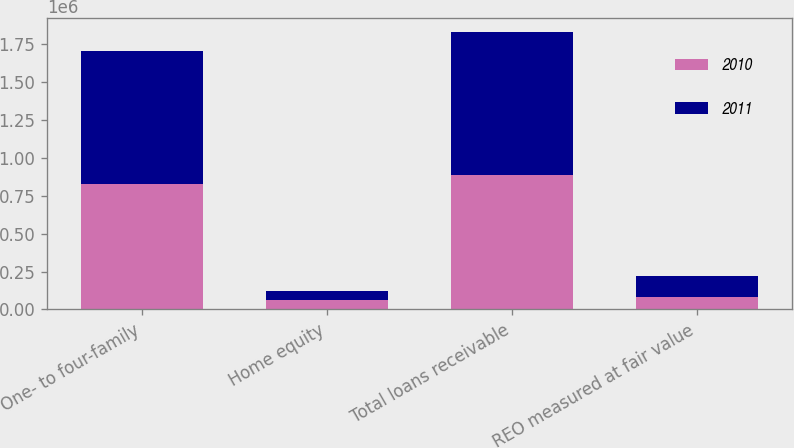Convert chart. <chart><loc_0><loc_0><loc_500><loc_500><stacked_bar_chart><ecel><fcel>One- to four-family<fcel>Home equity<fcel>Total loans receivable<fcel>REO measured at fair value<nl><fcel>2010<fcel>823338<fcel>61163<fcel>884501<fcel>81505<nl><fcel>2011<fcel>880044<fcel>61940<fcel>941984<fcel>140029<nl></chart> 